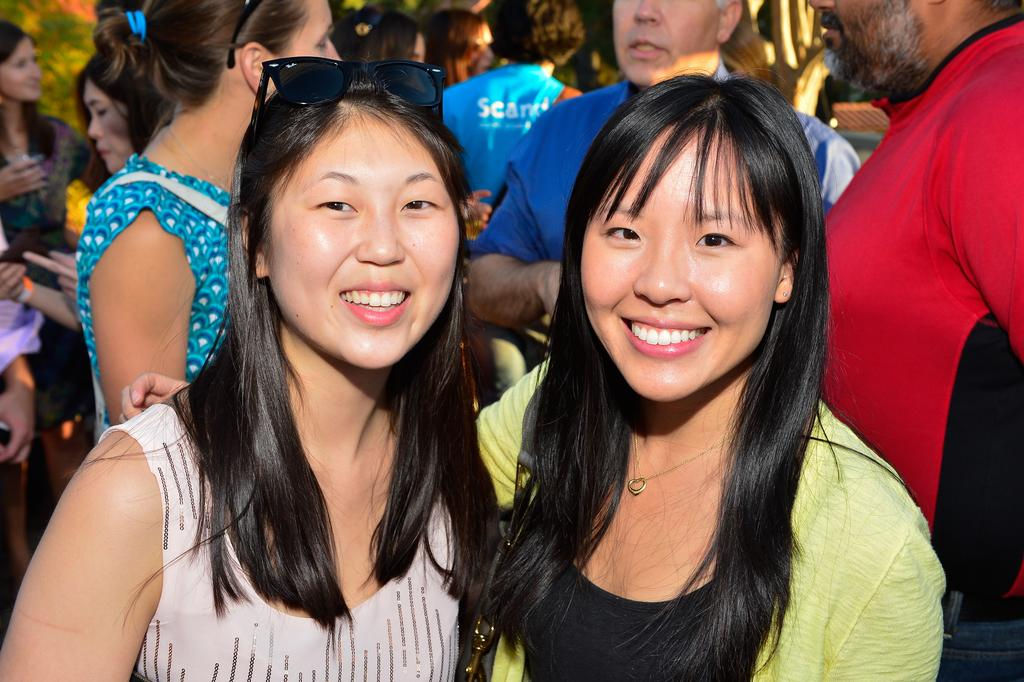How many ladies are present in the image? There are two ladies standing in the image. What is the facial expression of the ladies? The ladies are smiling. Are there any other people visible in the image? Yes, there are other people standing behind the ladies. What type of tax is being discussed by the ladies in the image? There is no indication in the image that the ladies are discussing any type of tax. 